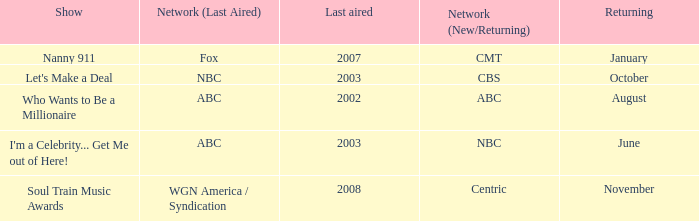When did soul train music awards return? November. 